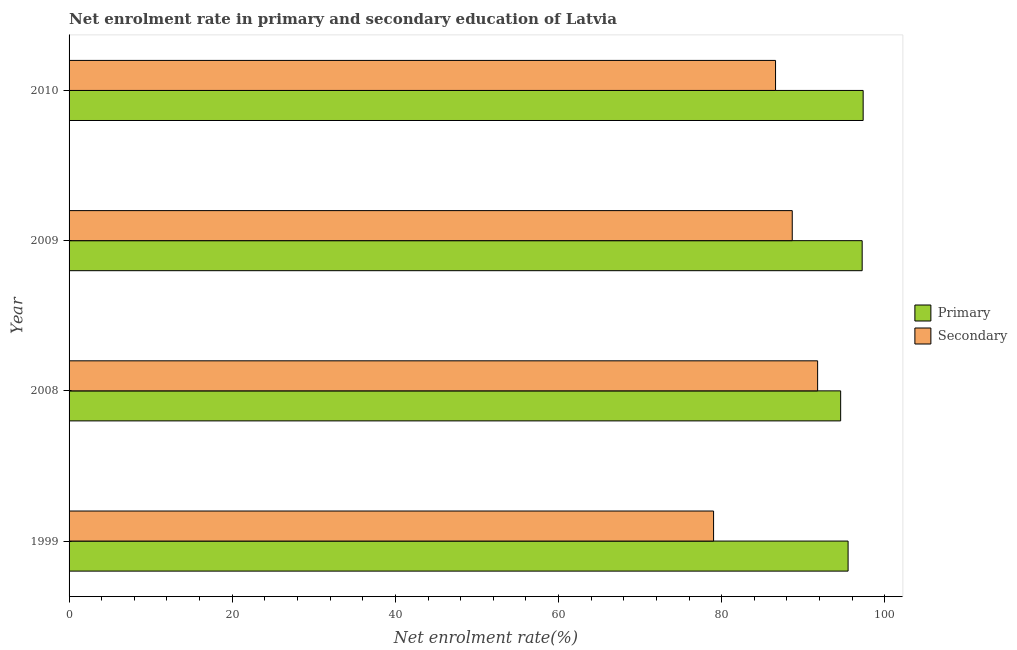How many bars are there on the 3rd tick from the top?
Keep it short and to the point. 2. What is the label of the 4th group of bars from the top?
Ensure brevity in your answer.  1999. In how many cases, is the number of bars for a given year not equal to the number of legend labels?
Provide a short and direct response. 0. What is the enrollment rate in primary education in 2010?
Make the answer very short. 97.35. Across all years, what is the maximum enrollment rate in primary education?
Make the answer very short. 97.35. Across all years, what is the minimum enrollment rate in secondary education?
Your response must be concise. 79.01. In which year was the enrollment rate in secondary education maximum?
Provide a succinct answer. 2008. In which year was the enrollment rate in primary education minimum?
Your answer should be very brief. 2008. What is the total enrollment rate in primary education in the graph?
Offer a terse response. 384.66. What is the difference between the enrollment rate in primary education in 1999 and that in 2008?
Offer a very short reply. 0.91. What is the difference between the enrollment rate in primary education in 1999 and the enrollment rate in secondary education in 2008?
Keep it short and to the point. 3.73. What is the average enrollment rate in secondary education per year?
Keep it short and to the point. 86.51. In the year 1999, what is the difference between the enrollment rate in primary education and enrollment rate in secondary education?
Your answer should be very brief. 16.49. What is the ratio of the enrollment rate in primary education in 2008 to that in 2010?
Offer a very short reply. 0.97. Is the enrollment rate in primary education in 2008 less than that in 2009?
Your answer should be compact. Yes. What is the difference between the highest and the second highest enrollment rate in primary education?
Provide a short and direct response. 0.12. What is the difference between the highest and the lowest enrollment rate in primary education?
Offer a terse response. 2.76. Is the sum of the enrollment rate in secondary education in 2008 and 2010 greater than the maximum enrollment rate in primary education across all years?
Provide a short and direct response. Yes. What does the 1st bar from the top in 2010 represents?
Make the answer very short. Secondary. What does the 1st bar from the bottom in 2009 represents?
Your answer should be very brief. Primary. How many bars are there?
Give a very brief answer. 8. Are all the bars in the graph horizontal?
Offer a terse response. Yes. How many years are there in the graph?
Your answer should be compact. 4. What is the difference between two consecutive major ticks on the X-axis?
Ensure brevity in your answer.  20. Does the graph contain any zero values?
Keep it short and to the point. No. Does the graph contain grids?
Your response must be concise. No. Where does the legend appear in the graph?
Make the answer very short. Center right. How many legend labels are there?
Ensure brevity in your answer.  2. How are the legend labels stacked?
Your answer should be compact. Vertical. What is the title of the graph?
Your answer should be compact. Net enrolment rate in primary and secondary education of Latvia. Does "Research and Development" appear as one of the legend labels in the graph?
Offer a terse response. No. What is the label or title of the X-axis?
Make the answer very short. Net enrolment rate(%). What is the Net enrolment rate(%) in Primary in 1999?
Your response must be concise. 95.5. What is the Net enrolment rate(%) in Secondary in 1999?
Your answer should be very brief. 79.01. What is the Net enrolment rate(%) in Primary in 2008?
Provide a short and direct response. 94.59. What is the Net enrolment rate(%) in Secondary in 2008?
Offer a terse response. 91.77. What is the Net enrolment rate(%) of Primary in 2009?
Offer a terse response. 97.23. What is the Net enrolment rate(%) of Secondary in 2009?
Ensure brevity in your answer.  88.65. What is the Net enrolment rate(%) in Primary in 2010?
Your answer should be very brief. 97.35. What is the Net enrolment rate(%) in Secondary in 2010?
Provide a short and direct response. 86.61. Across all years, what is the maximum Net enrolment rate(%) of Primary?
Your answer should be very brief. 97.35. Across all years, what is the maximum Net enrolment rate(%) of Secondary?
Offer a very short reply. 91.77. Across all years, what is the minimum Net enrolment rate(%) of Primary?
Provide a succinct answer. 94.59. Across all years, what is the minimum Net enrolment rate(%) in Secondary?
Offer a very short reply. 79.01. What is the total Net enrolment rate(%) of Primary in the graph?
Your answer should be very brief. 384.66. What is the total Net enrolment rate(%) in Secondary in the graph?
Offer a very short reply. 346.04. What is the difference between the Net enrolment rate(%) of Primary in 1999 and that in 2008?
Your response must be concise. 0.91. What is the difference between the Net enrolment rate(%) of Secondary in 1999 and that in 2008?
Ensure brevity in your answer.  -12.76. What is the difference between the Net enrolment rate(%) in Primary in 1999 and that in 2009?
Your answer should be very brief. -1.73. What is the difference between the Net enrolment rate(%) of Secondary in 1999 and that in 2009?
Give a very brief answer. -9.64. What is the difference between the Net enrolment rate(%) in Primary in 1999 and that in 2010?
Your answer should be compact. -1.85. What is the difference between the Net enrolment rate(%) in Secondary in 1999 and that in 2010?
Keep it short and to the point. -7.6. What is the difference between the Net enrolment rate(%) in Primary in 2008 and that in 2009?
Your response must be concise. -2.64. What is the difference between the Net enrolment rate(%) in Secondary in 2008 and that in 2009?
Your answer should be very brief. 3.11. What is the difference between the Net enrolment rate(%) in Primary in 2008 and that in 2010?
Offer a terse response. -2.76. What is the difference between the Net enrolment rate(%) of Secondary in 2008 and that in 2010?
Make the answer very short. 5.16. What is the difference between the Net enrolment rate(%) in Primary in 2009 and that in 2010?
Keep it short and to the point. -0.12. What is the difference between the Net enrolment rate(%) of Secondary in 2009 and that in 2010?
Offer a very short reply. 2.05. What is the difference between the Net enrolment rate(%) in Primary in 1999 and the Net enrolment rate(%) in Secondary in 2008?
Keep it short and to the point. 3.73. What is the difference between the Net enrolment rate(%) in Primary in 1999 and the Net enrolment rate(%) in Secondary in 2009?
Provide a short and direct response. 6.85. What is the difference between the Net enrolment rate(%) in Primary in 1999 and the Net enrolment rate(%) in Secondary in 2010?
Ensure brevity in your answer.  8.89. What is the difference between the Net enrolment rate(%) of Primary in 2008 and the Net enrolment rate(%) of Secondary in 2009?
Your answer should be very brief. 5.93. What is the difference between the Net enrolment rate(%) in Primary in 2008 and the Net enrolment rate(%) in Secondary in 2010?
Give a very brief answer. 7.98. What is the difference between the Net enrolment rate(%) in Primary in 2009 and the Net enrolment rate(%) in Secondary in 2010?
Make the answer very short. 10.62. What is the average Net enrolment rate(%) in Primary per year?
Keep it short and to the point. 96.17. What is the average Net enrolment rate(%) of Secondary per year?
Offer a terse response. 86.51. In the year 1999, what is the difference between the Net enrolment rate(%) of Primary and Net enrolment rate(%) of Secondary?
Keep it short and to the point. 16.49. In the year 2008, what is the difference between the Net enrolment rate(%) in Primary and Net enrolment rate(%) in Secondary?
Your response must be concise. 2.82. In the year 2009, what is the difference between the Net enrolment rate(%) of Primary and Net enrolment rate(%) of Secondary?
Provide a succinct answer. 8.57. In the year 2010, what is the difference between the Net enrolment rate(%) of Primary and Net enrolment rate(%) of Secondary?
Your answer should be compact. 10.74. What is the ratio of the Net enrolment rate(%) in Primary in 1999 to that in 2008?
Your response must be concise. 1.01. What is the ratio of the Net enrolment rate(%) of Secondary in 1999 to that in 2008?
Your answer should be very brief. 0.86. What is the ratio of the Net enrolment rate(%) of Primary in 1999 to that in 2009?
Your answer should be very brief. 0.98. What is the ratio of the Net enrolment rate(%) of Secondary in 1999 to that in 2009?
Keep it short and to the point. 0.89. What is the ratio of the Net enrolment rate(%) in Secondary in 1999 to that in 2010?
Make the answer very short. 0.91. What is the ratio of the Net enrolment rate(%) of Primary in 2008 to that in 2009?
Give a very brief answer. 0.97. What is the ratio of the Net enrolment rate(%) in Secondary in 2008 to that in 2009?
Your answer should be compact. 1.04. What is the ratio of the Net enrolment rate(%) of Primary in 2008 to that in 2010?
Offer a terse response. 0.97. What is the ratio of the Net enrolment rate(%) in Secondary in 2008 to that in 2010?
Provide a succinct answer. 1.06. What is the ratio of the Net enrolment rate(%) in Secondary in 2009 to that in 2010?
Give a very brief answer. 1.02. What is the difference between the highest and the second highest Net enrolment rate(%) in Primary?
Make the answer very short. 0.12. What is the difference between the highest and the second highest Net enrolment rate(%) of Secondary?
Give a very brief answer. 3.11. What is the difference between the highest and the lowest Net enrolment rate(%) of Primary?
Your response must be concise. 2.76. What is the difference between the highest and the lowest Net enrolment rate(%) in Secondary?
Make the answer very short. 12.76. 